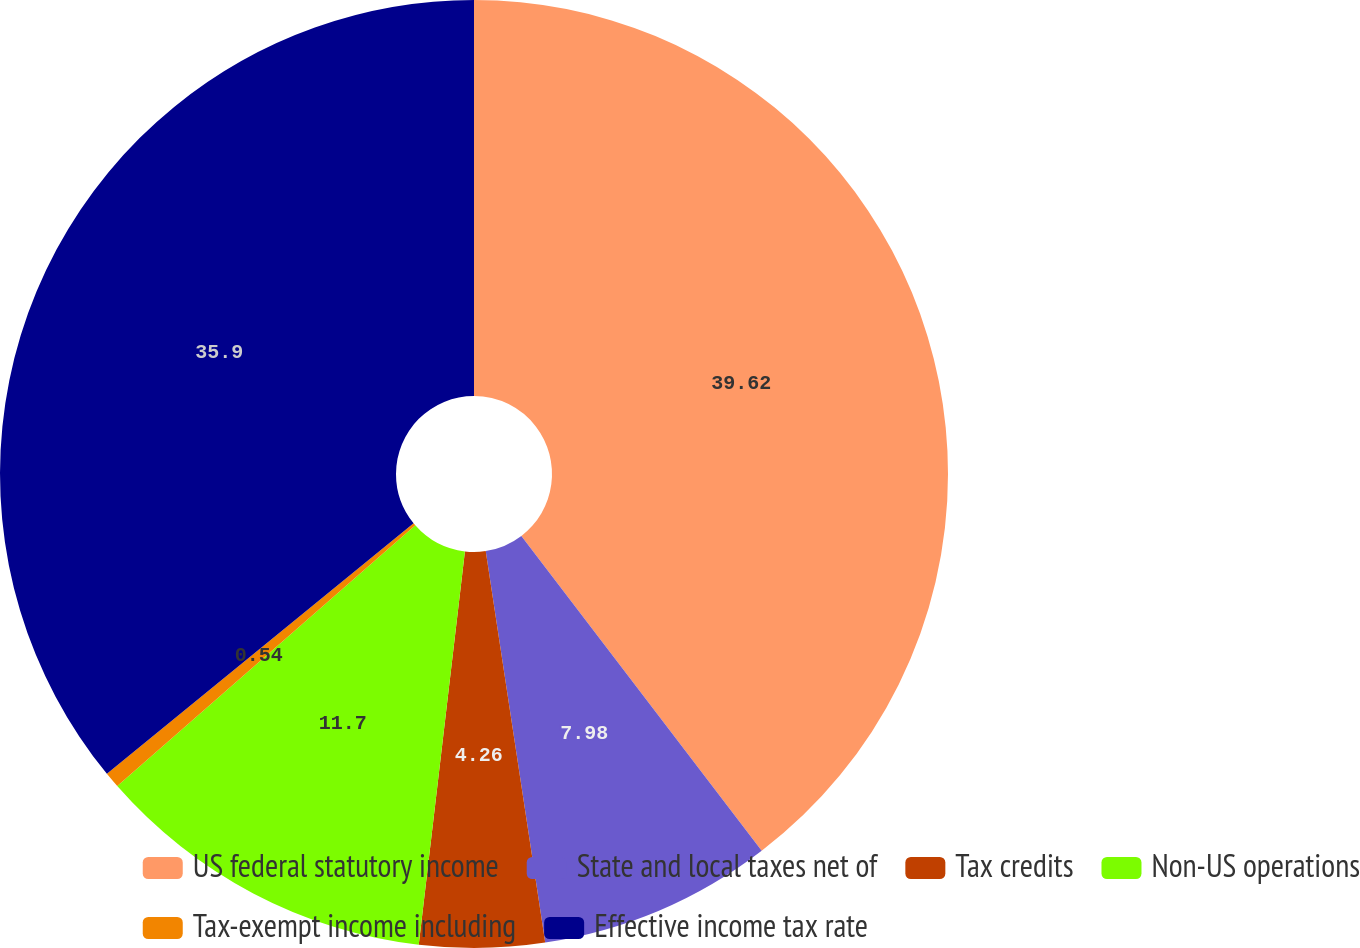<chart> <loc_0><loc_0><loc_500><loc_500><pie_chart><fcel>US federal statutory income<fcel>State and local taxes net of<fcel>Tax credits<fcel>Non-US operations<fcel>Tax-exempt income including<fcel>Effective income tax rate<nl><fcel>39.62%<fcel>7.98%<fcel>4.26%<fcel>11.7%<fcel>0.54%<fcel>35.9%<nl></chart> 